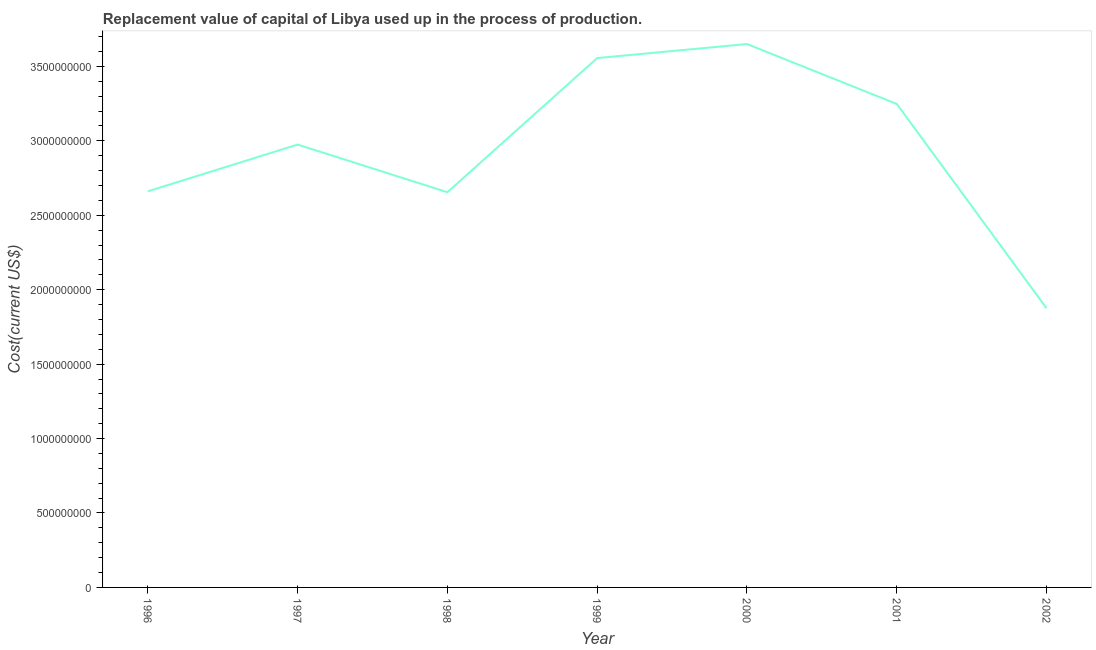What is the consumption of fixed capital in 2001?
Offer a very short reply. 3.25e+09. Across all years, what is the maximum consumption of fixed capital?
Ensure brevity in your answer.  3.65e+09. Across all years, what is the minimum consumption of fixed capital?
Keep it short and to the point. 1.88e+09. In which year was the consumption of fixed capital minimum?
Your answer should be compact. 2002. What is the sum of the consumption of fixed capital?
Offer a terse response. 2.06e+1. What is the difference between the consumption of fixed capital in 1997 and 2002?
Your answer should be very brief. 1.10e+09. What is the average consumption of fixed capital per year?
Ensure brevity in your answer.  2.95e+09. What is the median consumption of fixed capital?
Your answer should be very brief. 2.97e+09. In how many years, is the consumption of fixed capital greater than 700000000 US$?
Your response must be concise. 7. Do a majority of the years between 1998 and 1996 (inclusive) have consumption of fixed capital greater than 2100000000 US$?
Give a very brief answer. No. What is the ratio of the consumption of fixed capital in 2000 to that in 2001?
Give a very brief answer. 1.12. Is the consumption of fixed capital in 1996 less than that in 1997?
Your answer should be very brief. Yes. What is the difference between the highest and the second highest consumption of fixed capital?
Make the answer very short. 9.42e+07. What is the difference between the highest and the lowest consumption of fixed capital?
Your answer should be very brief. 1.77e+09. How many years are there in the graph?
Provide a succinct answer. 7. Are the values on the major ticks of Y-axis written in scientific E-notation?
Make the answer very short. No. Does the graph contain any zero values?
Your answer should be compact. No. Does the graph contain grids?
Make the answer very short. No. What is the title of the graph?
Make the answer very short. Replacement value of capital of Libya used up in the process of production. What is the label or title of the X-axis?
Offer a very short reply. Year. What is the label or title of the Y-axis?
Offer a terse response. Cost(current US$). What is the Cost(current US$) in 1996?
Your response must be concise. 2.66e+09. What is the Cost(current US$) of 1997?
Give a very brief answer. 2.97e+09. What is the Cost(current US$) in 1998?
Provide a succinct answer. 2.65e+09. What is the Cost(current US$) of 1999?
Offer a terse response. 3.56e+09. What is the Cost(current US$) in 2000?
Your response must be concise. 3.65e+09. What is the Cost(current US$) in 2001?
Make the answer very short. 3.25e+09. What is the Cost(current US$) of 2002?
Offer a terse response. 1.88e+09. What is the difference between the Cost(current US$) in 1996 and 1997?
Offer a terse response. -3.14e+08. What is the difference between the Cost(current US$) in 1996 and 1998?
Make the answer very short. 5.96e+06. What is the difference between the Cost(current US$) in 1996 and 1999?
Provide a succinct answer. -8.95e+08. What is the difference between the Cost(current US$) in 1996 and 2000?
Your answer should be compact. -9.90e+08. What is the difference between the Cost(current US$) in 1996 and 2001?
Make the answer very short. -5.87e+08. What is the difference between the Cost(current US$) in 1996 and 2002?
Your answer should be very brief. 7.85e+08. What is the difference between the Cost(current US$) in 1997 and 1998?
Provide a succinct answer. 3.20e+08. What is the difference between the Cost(current US$) in 1997 and 1999?
Offer a very short reply. -5.81e+08. What is the difference between the Cost(current US$) in 1997 and 2000?
Make the answer very short. -6.75e+08. What is the difference between the Cost(current US$) in 1997 and 2001?
Keep it short and to the point. -2.73e+08. What is the difference between the Cost(current US$) in 1997 and 2002?
Offer a terse response. 1.10e+09. What is the difference between the Cost(current US$) in 1998 and 1999?
Offer a terse response. -9.01e+08. What is the difference between the Cost(current US$) in 1998 and 2000?
Offer a terse response. -9.95e+08. What is the difference between the Cost(current US$) in 1998 and 2001?
Your answer should be compact. -5.93e+08. What is the difference between the Cost(current US$) in 1998 and 2002?
Your response must be concise. 7.79e+08. What is the difference between the Cost(current US$) in 1999 and 2000?
Your answer should be compact. -9.42e+07. What is the difference between the Cost(current US$) in 1999 and 2001?
Your response must be concise. 3.08e+08. What is the difference between the Cost(current US$) in 1999 and 2002?
Ensure brevity in your answer.  1.68e+09. What is the difference between the Cost(current US$) in 2000 and 2001?
Offer a very short reply. 4.02e+08. What is the difference between the Cost(current US$) in 2000 and 2002?
Ensure brevity in your answer.  1.77e+09. What is the difference between the Cost(current US$) in 2001 and 2002?
Provide a succinct answer. 1.37e+09. What is the ratio of the Cost(current US$) in 1996 to that in 1997?
Your answer should be very brief. 0.89. What is the ratio of the Cost(current US$) in 1996 to that in 1999?
Offer a very short reply. 0.75. What is the ratio of the Cost(current US$) in 1996 to that in 2000?
Provide a succinct answer. 0.73. What is the ratio of the Cost(current US$) in 1996 to that in 2001?
Give a very brief answer. 0.82. What is the ratio of the Cost(current US$) in 1996 to that in 2002?
Your answer should be compact. 1.42. What is the ratio of the Cost(current US$) in 1997 to that in 1998?
Your response must be concise. 1.12. What is the ratio of the Cost(current US$) in 1997 to that in 1999?
Your answer should be very brief. 0.84. What is the ratio of the Cost(current US$) in 1997 to that in 2000?
Keep it short and to the point. 0.81. What is the ratio of the Cost(current US$) in 1997 to that in 2001?
Offer a very short reply. 0.92. What is the ratio of the Cost(current US$) in 1997 to that in 2002?
Keep it short and to the point. 1.59. What is the ratio of the Cost(current US$) in 1998 to that in 1999?
Keep it short and to the point. 0.75. What is the ratio of the Cost(current US$) in 1998 to that in 2000?
Make the answer very short. 0.73. What is the ratio of the Cost(current US$) in 1998 to that in 2001?
Keep it short and to the point. 0.82. What is the ratio of the Cost(current US$) in 1998 to that in 2002?
Provide a short and direct response. 1.42. What is the ratio of the Cost(current US$) in 1999 to that in 2001?
Give a very brief answer. 1.09. What is the ratio of the Cost(current US$) in 1999 to that in 2002?
Make the answer very short. 1.9. What is the ratio of the Cost(current US$) in 2000 to that in 2001?
Offer a very short reply. 1.12. What is the ratio of the Cost(current US$) in 2000 to that in 2002?
Your response must be concise. 1.95. What is the ratio of the Cost(current US$) in 2001 to that in 2002?
Ensure brevity in your answer.  1.73. 